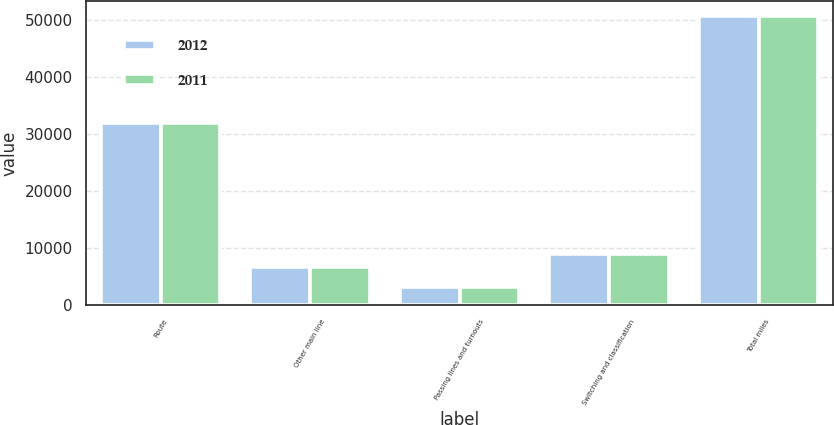<chart> <loc_0><loc_0><loc_500><loc_500><stacked_bar_chart><ecel><fcel>Route<fcel>Other main line<fcel>Passing lines and turnouts<fcel>Switching and classification<fcel>Total miles<nl><fcel>2012<fcel>31868<fcel>6715<fcel>3124<fcel>9046<fcel>50753<nl><fcel>2011<fcel>31898<fcel>6644<fcel>3112<fcel>8999<fcel>50653<nl></chart> 